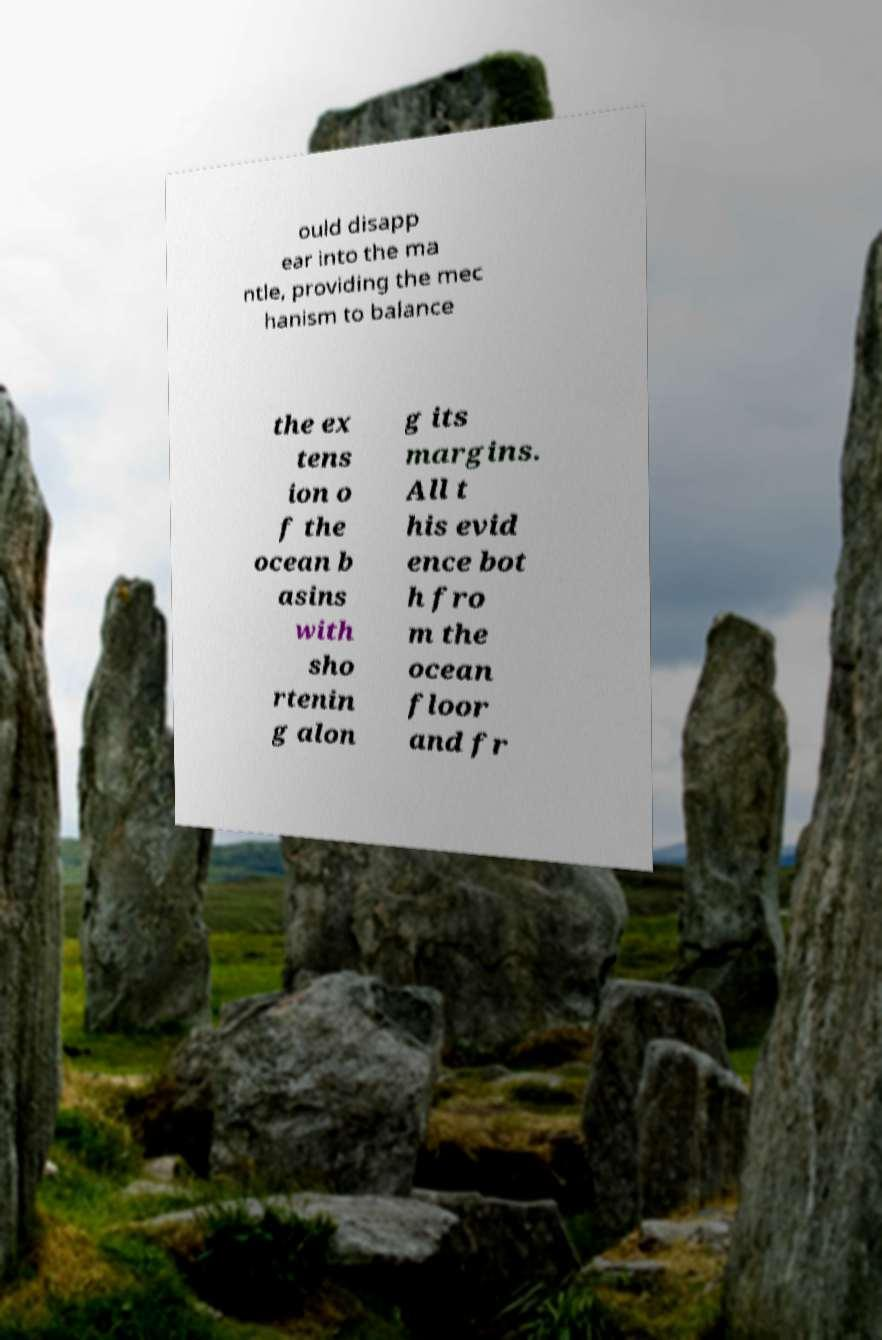There's text embedded in this image that I need extracted. Can you transcribe it verbatim? ould disapp ear into the ma ntle, providing the mec hanism to balance the ex tens ion o f the ocean b asins with sho rtenin g alon g its margins. All t his evid ence bot h fro m the ocean floor and fr 